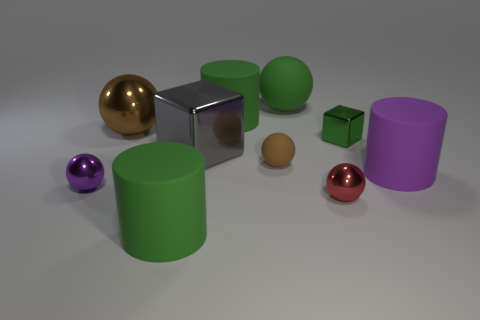Are there any brown metallic objects that have the same shape as the tiny red metal thing?
Keep it short and to the point. Yes. Does the brown object that is to the right of the big gray metal object have the same shape as the metal thing on the left side of the brown shiny sphere?
Ensure brevity in your answer.  Yes. Are there any spheres of the same size as the brown matte object?
Keep it short and to the point. Yes. Is the number of tiny cubes in front of the purple rubber cylinder the same as the number of green metallic blocks that are left of the large cube?
Give a very brief answer. Yes. Is the cylinder behind the small green thing made of the same material as the tiny thing to the left of the big gray shiny block?
Your answer should be very brief. No. What is the small brown sphere made of?
Offer a terse response. Rubber. What number of other things are there of the same color as the small cube?
Give a very brief answer. 3. Is the color of the big metal sphere the same as the large cube?
Provide a short and direct response. No. How many tiny red rubber things are there?
Provide a short and direct response. 0. There is a brown ball right of the large thing that is in front of the big purple thing; what is it made of?
Provide a short and direct response. Rubber. 